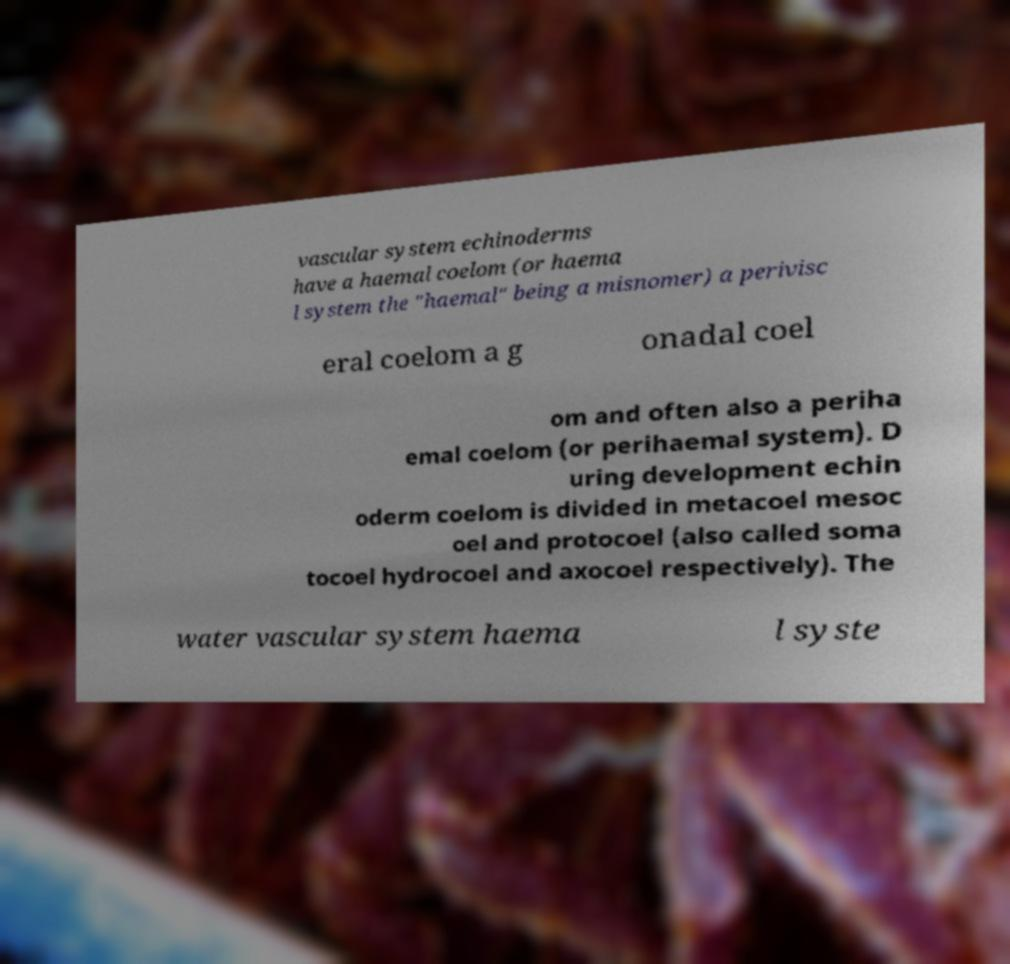Please identify and transcribe the text found in this image. vascular system echinoderms have a haemal coelom (or haema l system the "haemal" being a misnomer) a perivisc eral coelom a g onadal coel om and often also a periha emal coelom (or perihaemal system). D uring development echin oderm coelom is divided in metacoel mesoc oel and protocoel (also called soma tocoel hydrocoel and axocoel respectively). The water vascular system haema l syste 